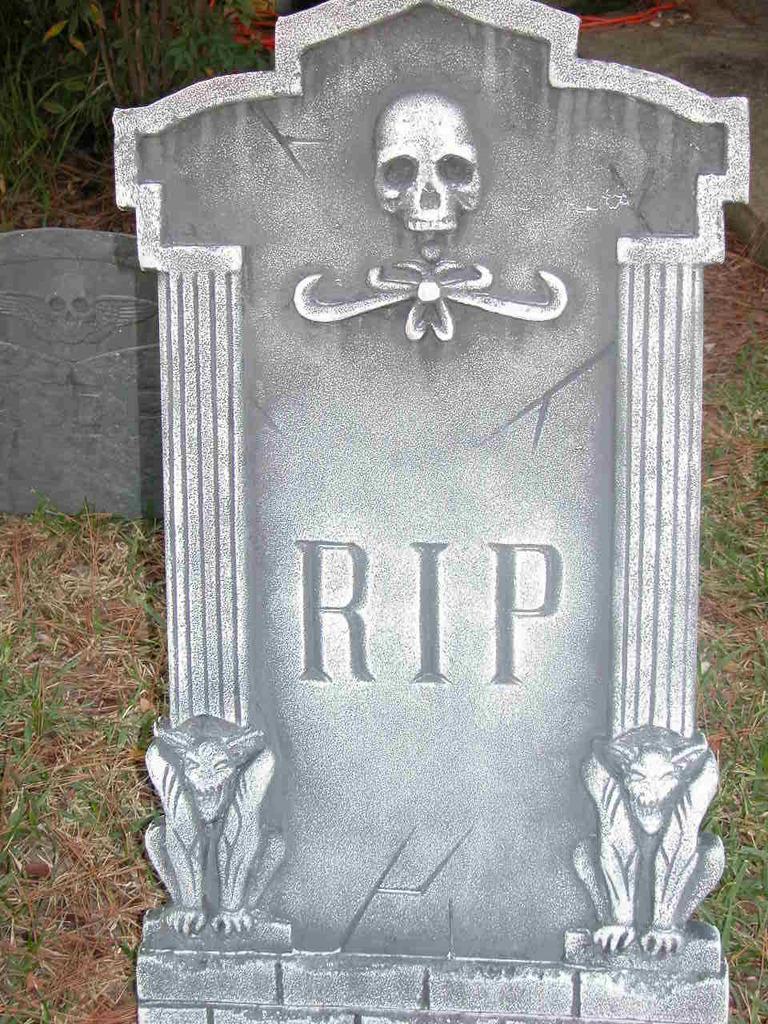In one or two sentences, can you explain what this image depicts? In this image there are two cemeteries on the grassland. Left top there are plants. Right top there is a rock on the grassland. 